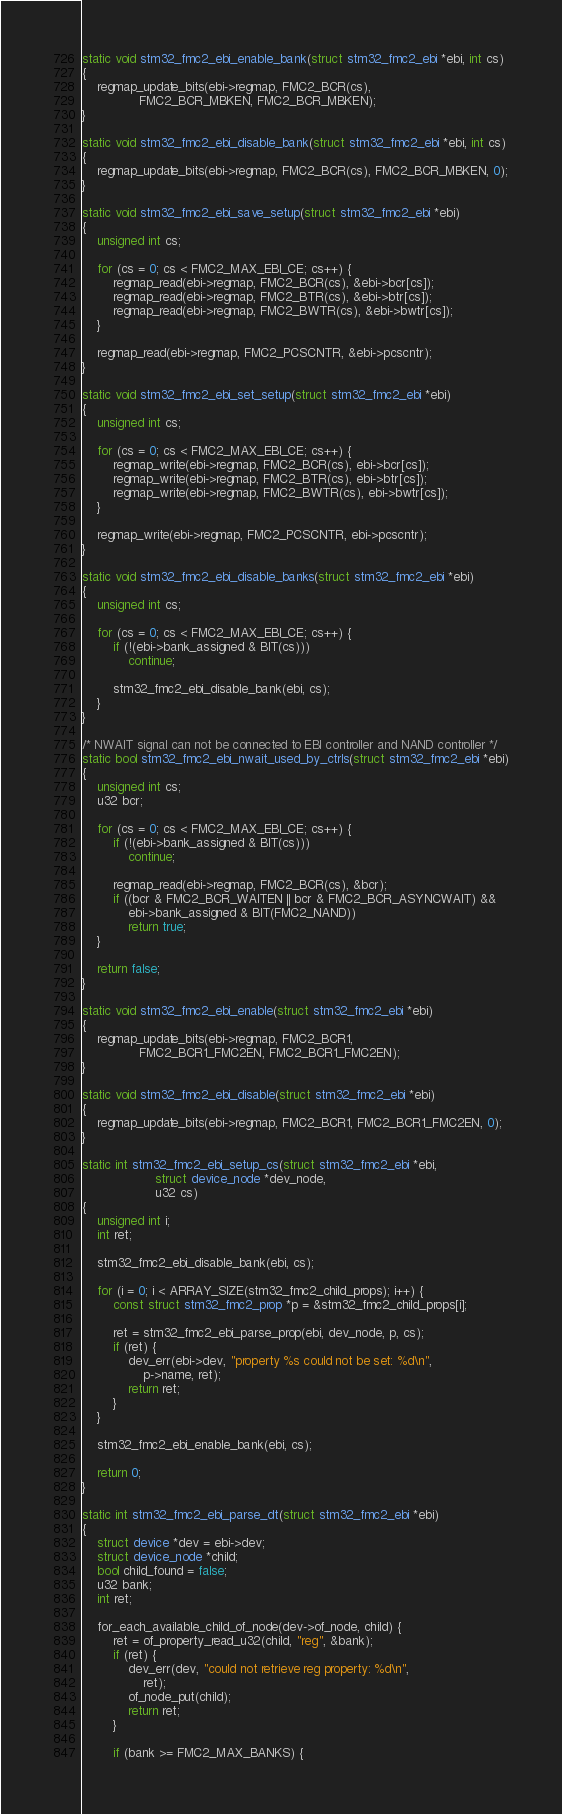<code> <loc_0><loc_0><loc_500><loc_500><_C_>static void stm32_fmc2_ebi_enable_bank(struct stm32_fmc2_ebi *ebi, int cs)
{
	regmap_update_bits(ebi->regmap, FMC2_BCR(cs),
			   FMC2_BCR_MBKEN, FMC2_BCR_MBKEN);
}

static void stm32_fmc2_ebi_disable_bank(struct stm32_fmc2_ebi *ebi, int cs)
{
	regmap_update_bits(ebi->regmap, FMC2_BCR(cs), FMC2_BCR_MBKEN, 0);
}

static void stm32_fmc2_ebi_save_setup(struct stm32_fmc2_ebi *ebi)
{
	unsigned int cs;

	for (cs = 0; cs < FMC2_MAX_EBI_CE; cs++) {
		regmap_read(ebi->regmap, FMC2_BCR(cs), &ebi->bcr[cs]);
		regmap_read(ebi->regmap, FMC2_BTR(cs), &ebi->btr[cs]);
		regmap_read(ebi->regmap, FMC2_BWTR(cs), &ebi->bwtr[cs]);
	}

	regmap_read(ebi->regmap, FMC2_PCSCNTR, &ebi->pcscntr);
}

static void stm32_fmc2_ebi_set_setup(struct stm32_fmc2_ebi *ebi)
{
	unsigned int cs;

	for (cs = 0; cs < FMC2_MAX_EBI_CE; cs++) {
		regmap_write(ebi->regmap, FMC2_BCR(cs), ebi->bcr[cs]);
		regmap_write(ebi->regmap, FMC2_BTR(cs), ebi->btr[cs]);
		regmap_write(ebi->regmap, FMC2_BWTR(cs), ebi->bwtr[cs]);
	}

	regmap_write(ebi->regmap, FMC2_PCSCNTR, ebi->pcscntr);
}

static void stm32_fmc2_ebi_disable_banks(struct stm32_fmc2_ebi *ebi)
{
	unsigned int cs;

	for (cs = 0; cs < FMC2_MAX_EBI_CE; cs++) {
		if (!(ebi->bank_assigned & BIT(cs)))
			continue;

		stm32_fmc2_ebi_disable_bank(ebi, cs);
	}
}

/* NWAIT signal can not be connected to EBI controller and NAND controller */
static bool stm32_fmc2_ebi_nwait_used_by_ctrls(struct stm32_fmc2_ebi *ebi)
{
	unsigned int cs;
	u32 bcr;

	for (cs = 0; cs < FMC2_MAX_EBI_CE; cs++) {
		if (!(ebi->bank_assigned & BIT(cs)))
			continue;

		regmap_read(ebi->regmap, FMC2_BCR(cs), &bcr);
		if ((bcr & FMC2_BCR_WAITEN || bcr & FMC2_BCR_ASYNCWAIT) &&
		    ebi->bank_assigned & BIT(FMC2_NAND))
			return true;
	}

	return false;
}

static void stm32_fmc2_ebi_enable(struct stm32_fmc2_ebi *ebi)
{
	regmap_update_bits(ebi->regmap, FMC2_BCR1,
			   FMC2_BCR1_FMC2EN, FMC2_BCR1_FMC2EN);
}

static void stm32_fmc2_ebi_disable(struct stm32_fmc2_ebi *ebi)
{
	regmap_update_bits(ebi->regmap, FMC2_BCR1, FMC2_BCR1_FMC2EN, 0);
}

static int stm32_fmc2_ebi_setup_cs(struct stm32_fmc2_ebi *ebi,
				   struct device_node *dev_node,
				   u32 cs)
{
	unsigned int i;
	int ret;

	stm32_fmc2_ebi_disable_bank(ebi, cs);

	for (i = 0; i < ARRAY_SIZE(stm32_fmc2_child_props); i++) {
		const struct stm32_fmc2_prop *p = &stm32_fmc2_child_props[i];

		ret = stm32_fmc2_ebi_parse_prop(ebi, dev_node, p, cs);
		if (ret) {
			dev_err(ebi->dev, "property %s could not be set: %d\n",
				p->name, ret);
			return ret;
		}
	}

	stm32_fmc2_ebi_enable_bank(ebi, cs);

	return 0;
}

static int stm32_fmc2_ebi_parse_dt(struct stm32_fmc2_ebi *ebi)
{
	struct device *dev = ebi->dev;
	struct device_node *child;
	bool child_found = false;
	u32 bank;
	int ret;

	for_each_available_child_of_node(dev->of_node, child) {
		ret = of_property_read_u32(child, "reg", &bank);
		if (ret) {
			dev_err(dev, "could not retrieve reg property: %d\n",
				ret);
			of_node_put(child);
			return ret;
		}

		if (bank >= FMC2_MAX_BANKS) {</code> 